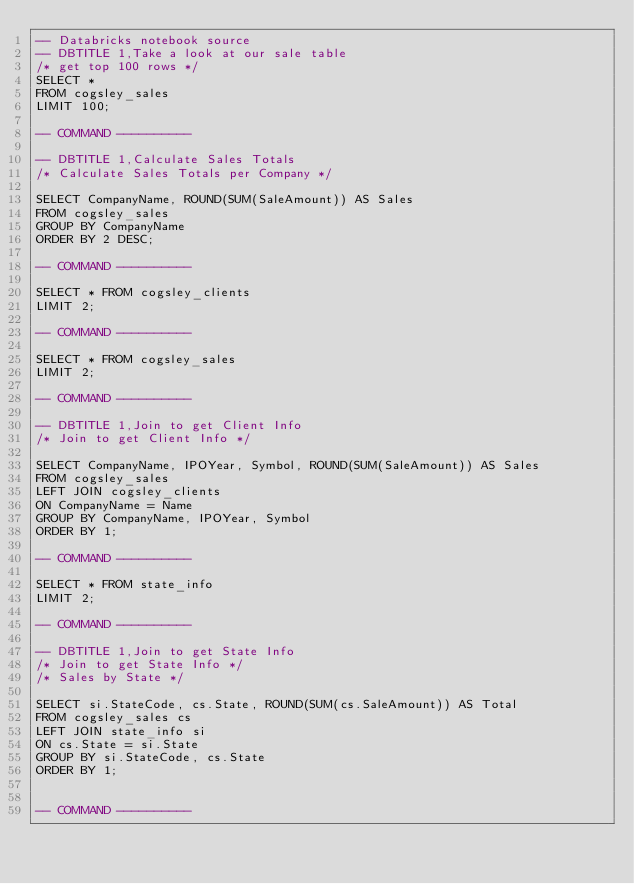Convert code to text. <code><loc_0><loc_0><loc_500><loc_500><_SQL_>-- Databricks notebook source
-- DBTITLE 1,Take a look at our sale table
/* get top 100 rows */
SELECT *
FROM cogsley_sales
LIMIT 100;

-- COMMAND ----------

-- DBTITLE 1,Calculate Sales Totals
/* Calculate Sales Totals per Company */

SELECT CompanyName, ROUND(SUM(SaleAmount)) AS Sales 
FROM cogsley_sales
GROUP BY CompanyName
ORDER BY 2 DESC;

-- COMMAND ----------

SELECT * FROM cogsley_clients
LIMIT 2;

-- COMMAND ----------

SELECT * FROM cogsley_sales
LIMIT 2;

-- COMMAND ----------

-- DBTITLE 1,Join to get Client Info
/* Join to get Client Info */

SELECT CompanyName, IPOYear, Symbol, ROUND(SUM(SaleAmount)) AS Sales
FROM cogsley_sales
LEFT JOIN cogsley_clients
ON CompanyName = Name
GROUP BY CompanyName, IPOYear, Symbol 
ORDER BY 1;

-- COMMAND ----------

SELECT * FROM state_info
LIMIT 2;

-- COMMAND ----------

-- DBTITLE 1,Join to get State Info
/* Join to get State Info */
/* Sales by State */

SELECT si.StateCode, cs.State, ROUND(SUM(cs.SaleAmount)) AS Total
FROM cogsley_sales cs
LEFT JOIN state_info si
ON cs.State = si.State
GROUP BY si.StateCode, cs.State
ORDER BY 1;


-- COMMAND ----------


</code> 